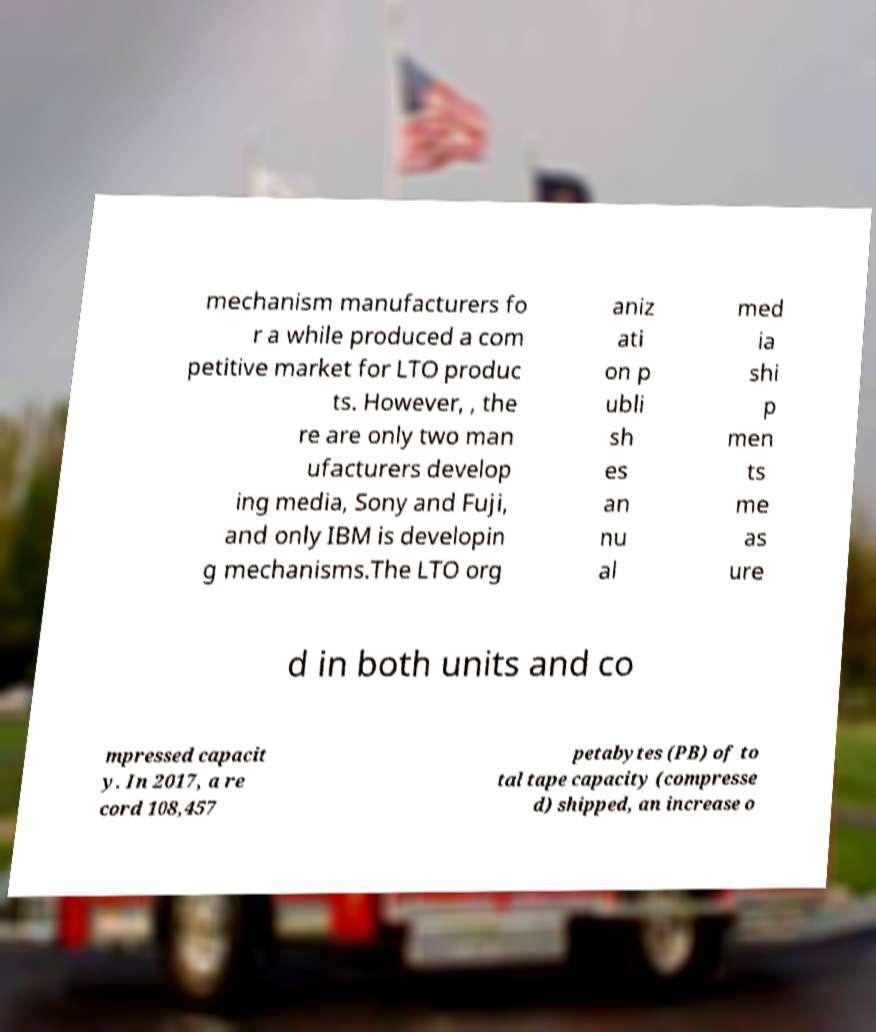Can you accurately transcribe the text from the provided image for me? mechanism manufacturers fo r a while produced a com petitive market for LTO produc ts. However, , the re are only two man ufacturers develop ing media, Sony and Fuji, and only IBM is developin g mechanisms.The LTO org aniz ati on p ubli sh es an nu al med ia shi p men ts me as ure d in both units and co mpressed capacit y. In 2017, a re cord 108,457 petabytes (PB) of to tal tape capacity (compresse d) shipped, an increase o 